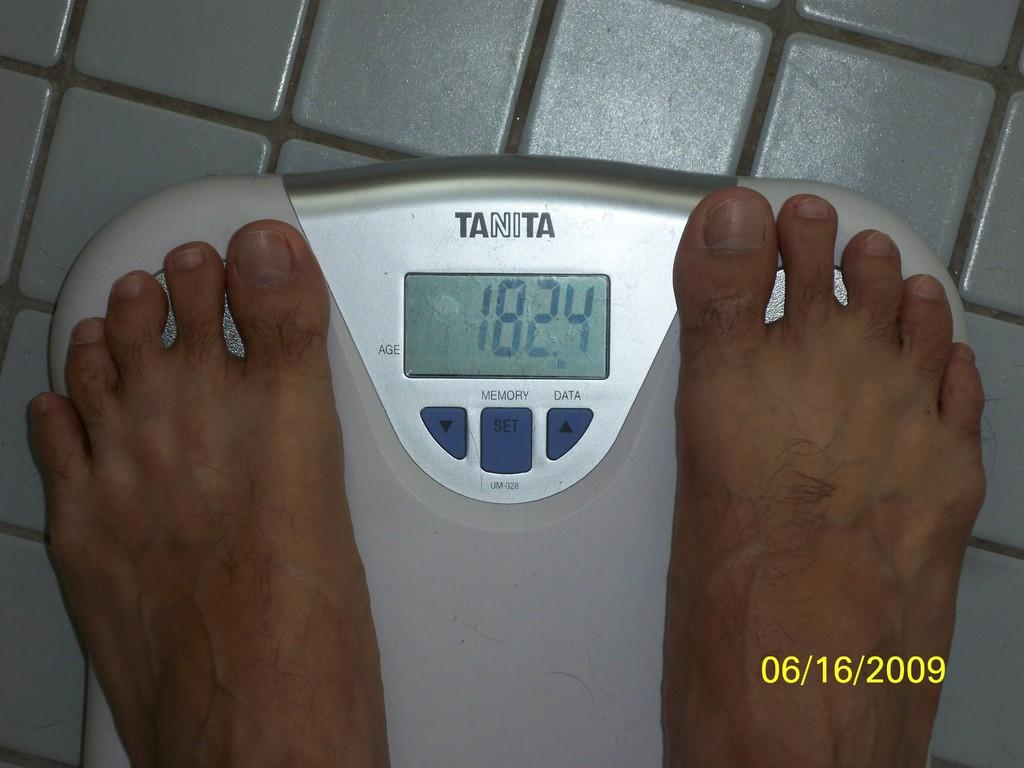<image>
Relay a brief, clear account of the picture shown. someone standing on tanita digital scales showing weight of 182.4 from june 16,2009 